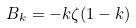<formula> <loc_0><loc_0><loc_500><loc_500>B _ { k } = - k \zeta ( 1 - k )</formula> 